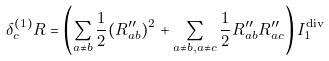<formula> <loc_0><loc_0><loc_500><loc_500>\delta ^ { ( 1 ) } _ { c } R = \left ( \sum _ { a \neq b } \frac { 1 } { 2 } ( R ^ { \prime \prime } _ { a b } ) ^ { 2 } + \sum _ { a \neq b , a \neq c } \frac { 1 } { 2 } R ^ { \prime \prime } _ { a b } R ^ { \prime \prime } _ { a c } \right ) I _ { 1 } ^ { \text {div} }</formula> 